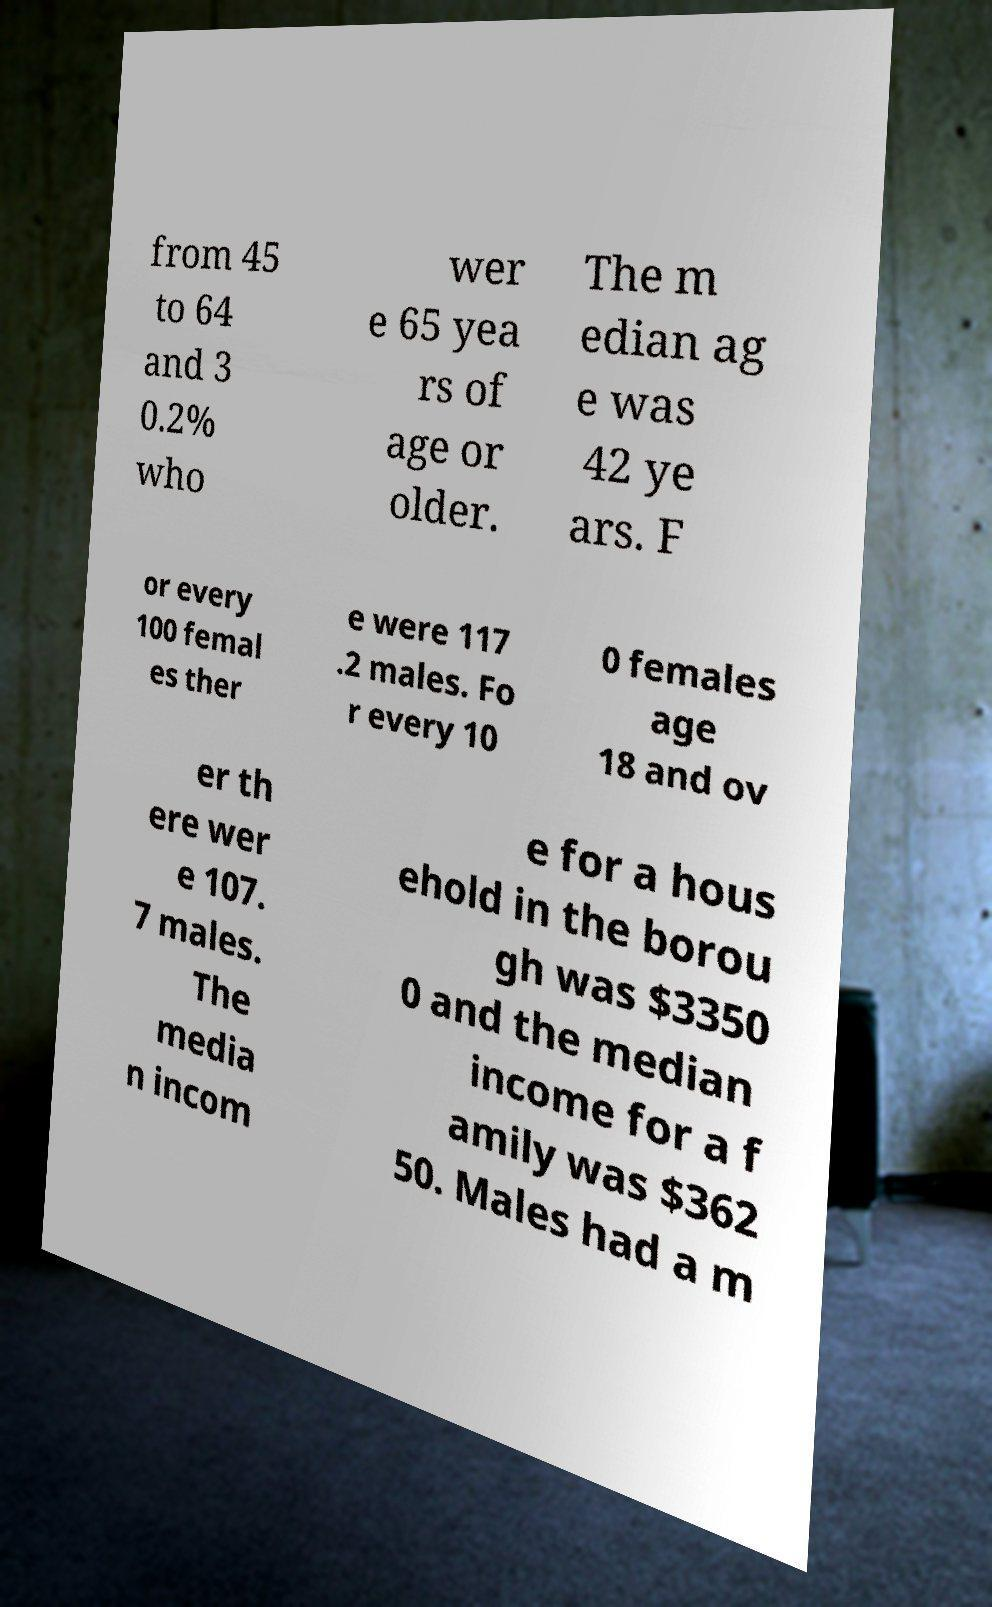There's text embedded in this image that I need extracted. Can you transcribe it verbatim? from 45 to 64 and 3 0.2% who wer e 65 yea rs of age or older. The m edian ag e was 42 ye ars. F or every 100 femal es ther e were 117 .2 males. Fo r every 10 0 females age 18 and ov er th ere wer e 107. 7 males. The media n incom e for a hous ehold in the borou gh was $3350 0 and the median income for a f amily was $362 50. Males had a m 